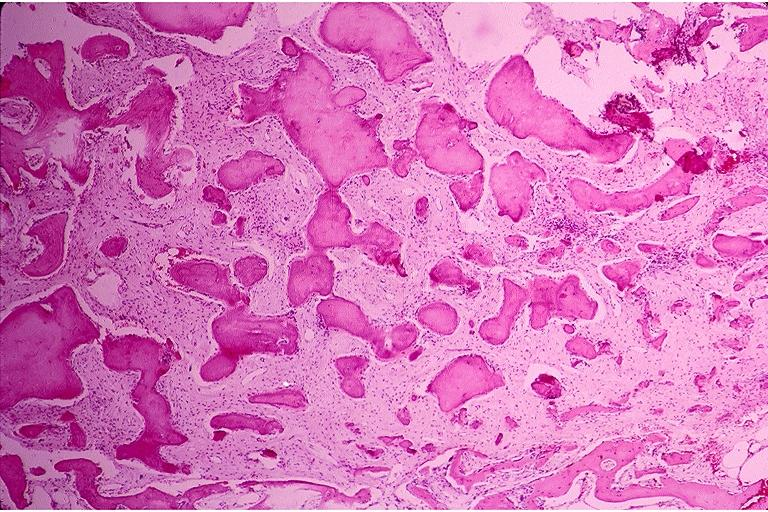what is present?
Answer the question using a single word or phrase. Oral 